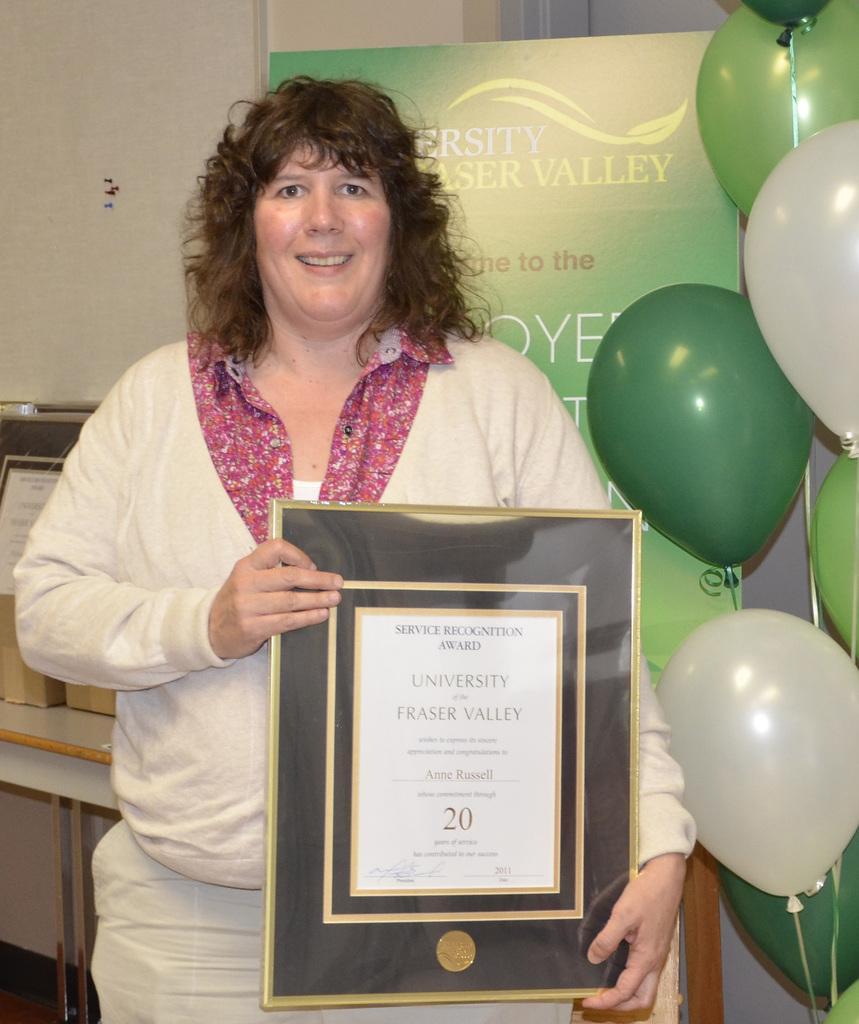Can you describe this image briefly? In this image there is a woman standing by holding the certificate. Behind her there is a banner. On the right side there are balloons. On the left side there is a table on which there are boxes. 